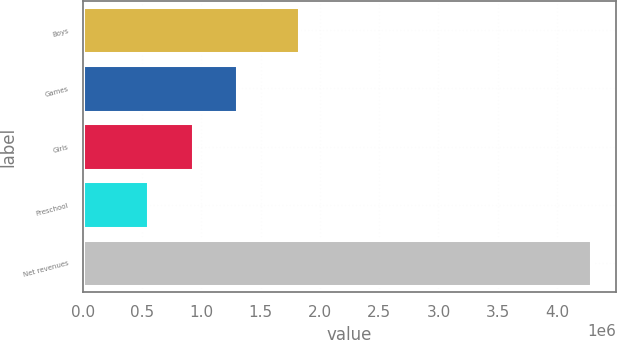<chart> <loc_0><loc_0><loc_500><loc_500><bar_chart><fcel>Boys<fcel>Games<fcel>Girls<fcel>Preschool<fcel>Net revenues<nl><fcel>1.82154e+06<fcel>1.2995e+06<fcel>926240<fcel>552979<fcel>4.28559e+06<nl></chart> 